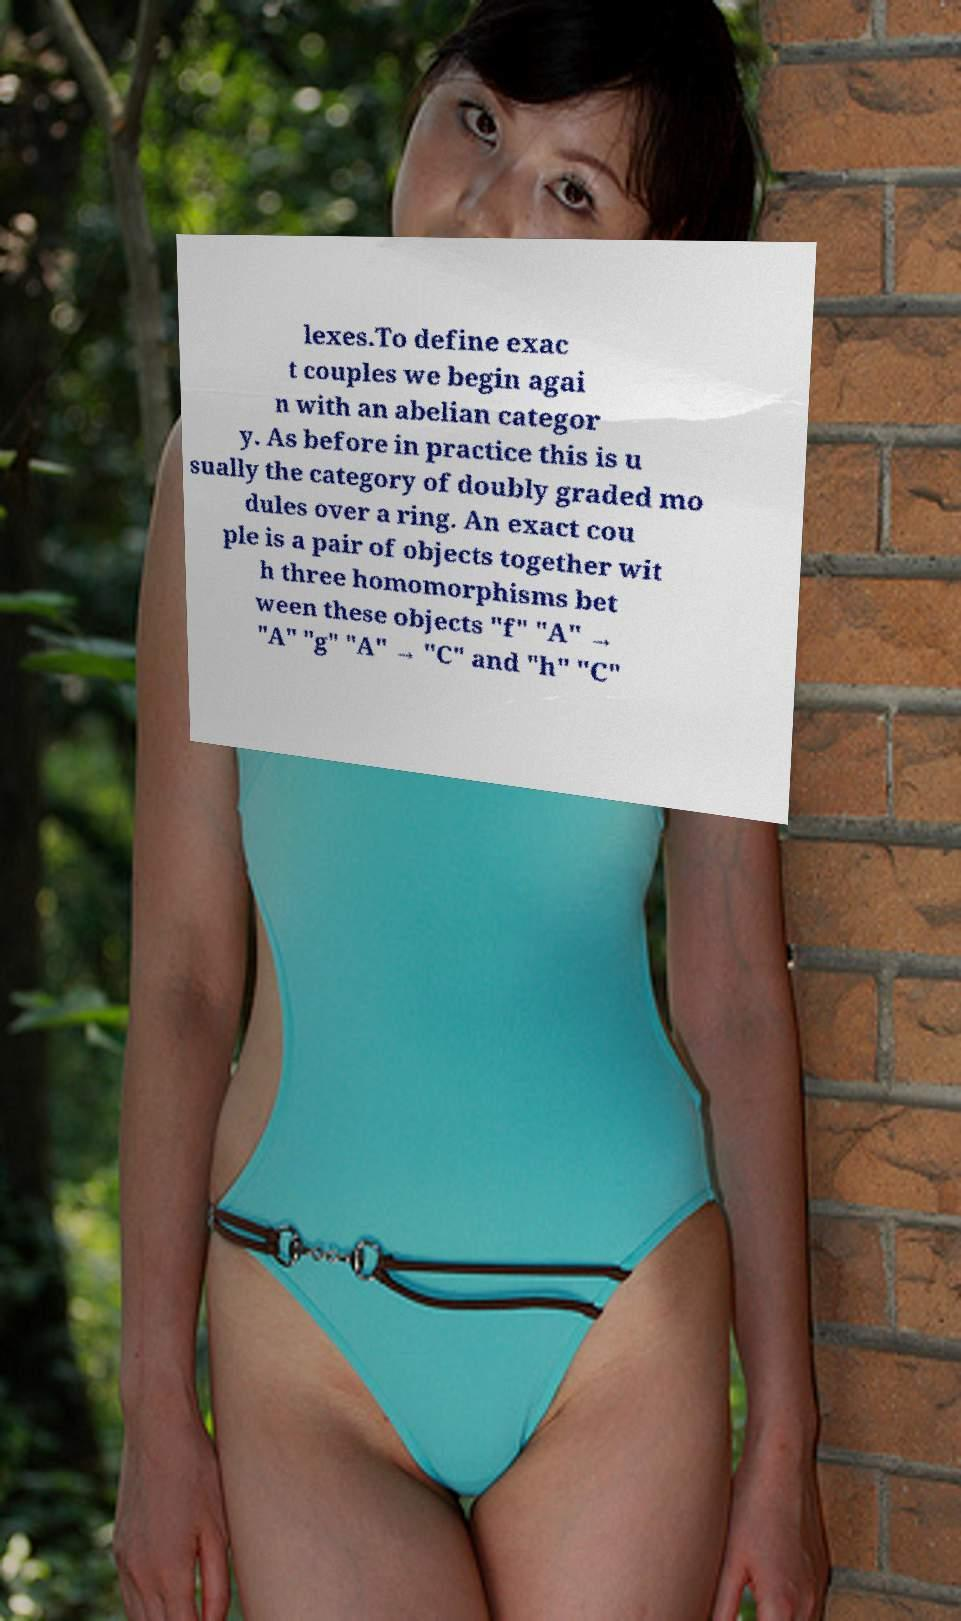Can you read and provide the text displayed in the image?This photo seems to have some interesting text. Can you extract and type it out for me? lexes.To define exac t couples we begin agai n with an abelian categor y. As before in practice this is u sually the category of doubly graded mo dules over a ring. An exact cou ple is a pair of objects together wit h three homomorphisms bet ween these objects "f" "A" → "A" "g" "A" → "C" and "h" "C" 